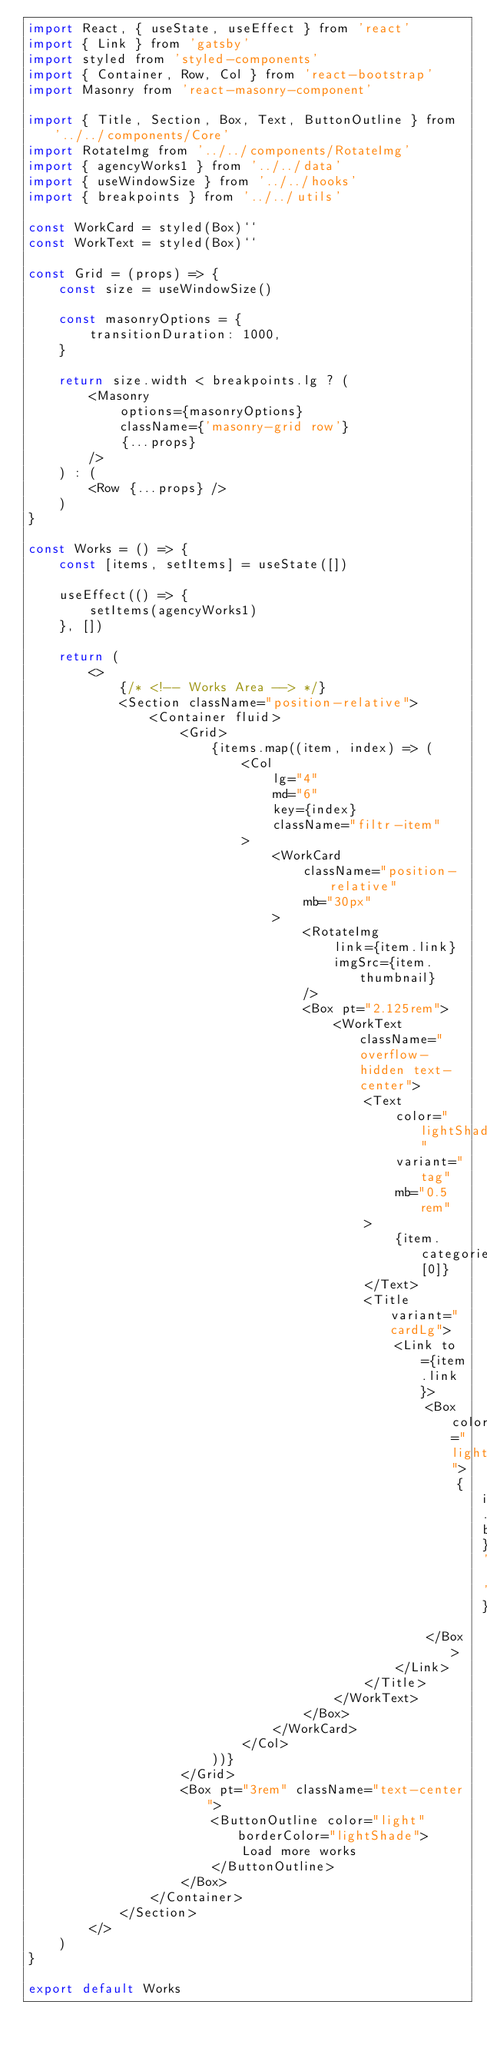Convert code to text. <code><loc_0><loc_0><loc_500><loc_500><_JavaScript_>import React, { useState, useEffect } from 'react'
import { Link } from 'gatsby'
import styled from 'styled-components'
import { Container, Row, Col } from 'react-bootstrap'
import Masonry from 'react-masonry-component'

import { Title, Section, Box, Text, ButtonOutline } from '../../components/Core'
import RotateImg from '../../components/RotateImg'
import { agencyWorks1 } from '../../data'
import { useWindowSize } from '../../hooks'
import { breakpoints } from '../../utils'

const WorkCard = styled(Box)``
const WorkText = styled(Box)``

const Grid = (props) => {
    const size = useWindowSize()

    const masonryOptions = {
        transitionDuration: 1000,
    }

    return size.width < breakpoints.lg ? (
        <Masonry
            options={masonryOptions}
            className={'masonry-grid row'}
            {...props}
        />
    ) : (
        <Row {...props} />
    )
}

const Works = () => {
    const [items, setItems] = useState([])

    useEffect(() => {
        setItems(agencyWorks1)
    }, [])

    return (
        <>
            {/* <!-- Works Area --> */}
            <Section className="position-relative">
                <Container fluid>
                    <Grid>
                        {items.map((item, index) => (
                            <Col
                                lg="4"
                                md="6"
                                key={index}
                                className="filtr-item"
                            >
                                <WorkCard
                                    className="position-relative"
                                    mb="30px"
                                >
                                    <RotateImg
                                        link={item.link}
                                        imgSrc={item.thumbnail}
                                    />
                                    <Box pt="2.125rem">
                                        <WorkText className="overflow-hidden text-center">
                                            <Text
                                                color="lightShade"
                                                variant="tag"
                                                mb="0.5rem"
                                            >
                                                {item.categories[0]}
                                            </Text>
                                            <Title variant="cardLg">
                                                <Link to={item.link}>
                                                    <Box color="light">
                                                        {item.brand}{' '}
                                                    </Box>
                                                </Link>
                                            </Title>
                                        </WorkText>
                                    </Box>
                                </WorkCard>
                            </Col>
                        ))}
                    </Grid>
                    <Box pt="3rem" className="text-center">
                        <ButtonOutline color="light" borderColor="lightShade">
                            Load more works
                        </ButtonOutline>
                    </Box>
                </Container>
            </Section>
        </>
    )
}

export default Works
</code> 